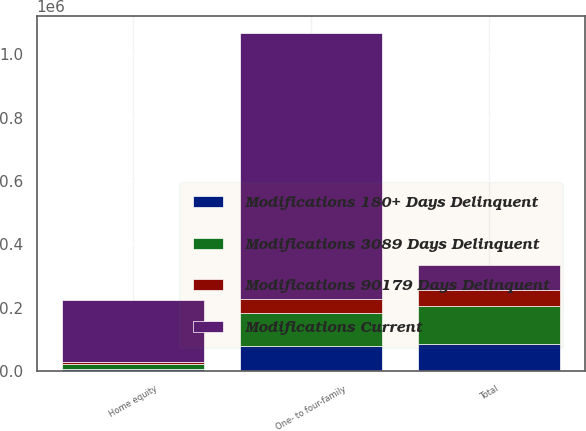Convert chart to OTSL. <chart><loc_0><loc_0><loc_500><loc_500><stacked_bar_chart><ecel><fcel>One- to four-family<fcel>Home equity<fcel>Total<nl><fcel>Modifications Current<fcel>838020<fcel>195021<fcel>79102<nl><fcel>Modifications 3089 Days Delinquent<fcel>105142<fcel>15107<fcel>120249<nl><fcel>Modifications 90179 Days Delinquent<fcel>43905<fcel>6173<fcel>50078<nl><fcel>Modifications 180+ Days Delinquent<fcel>79102<fcel>7118<fcel>86220<nl></chart> 